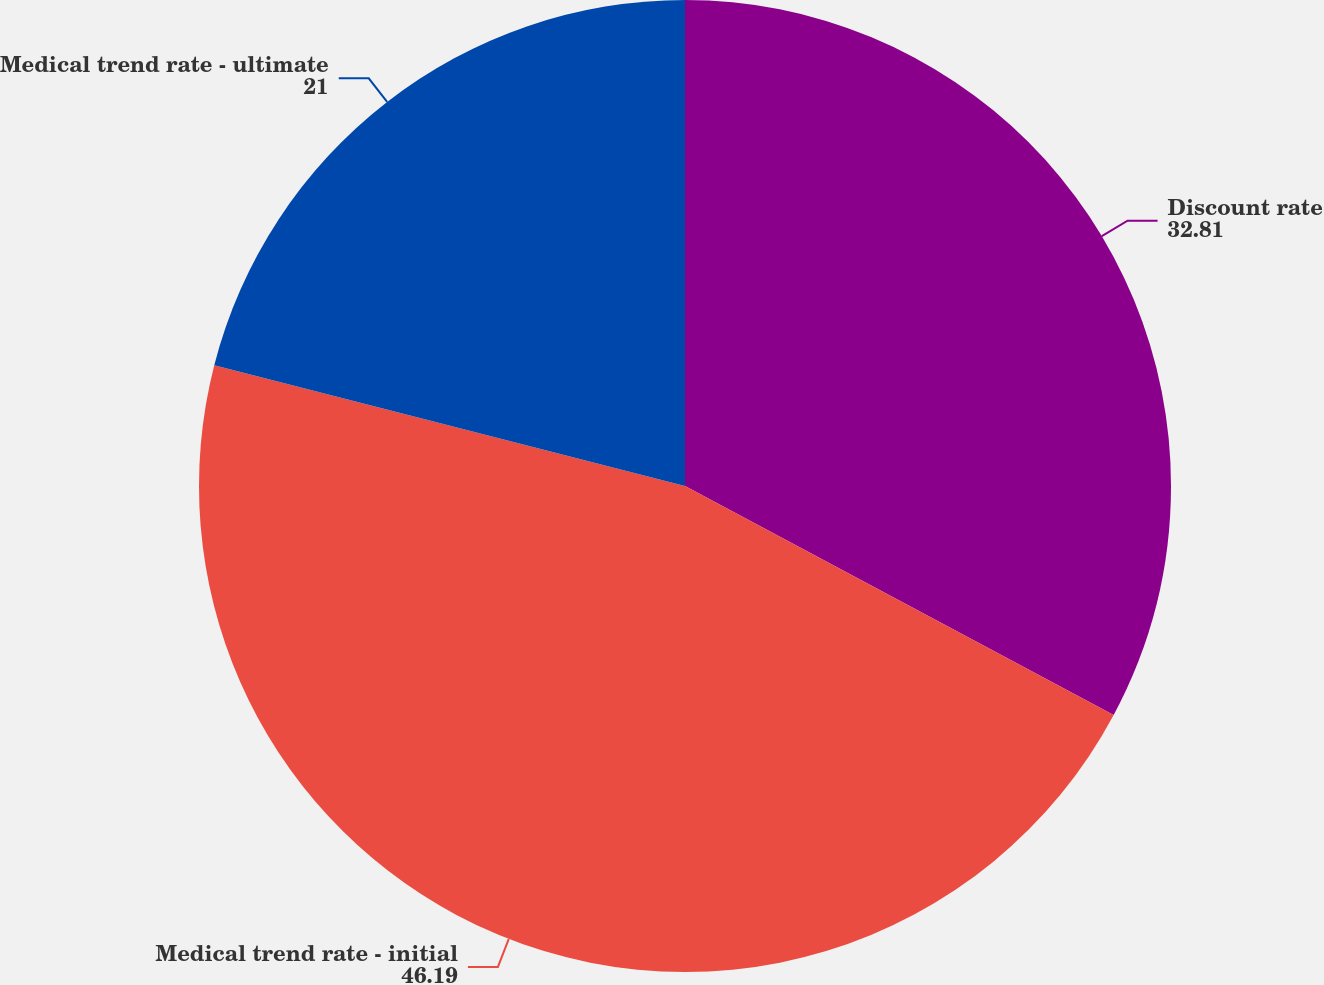Convert chart to OTSL. <chart><loc_0><loc_0><loc_500><loc_500><pie_chart><fcel>Discount rate<fcel>Medical trend rate - initial<fcel>Medical trend rate - ultimate<nl><fcel>32.81%<fcel>46.19%<fcel>21.0%<nl></chart> 